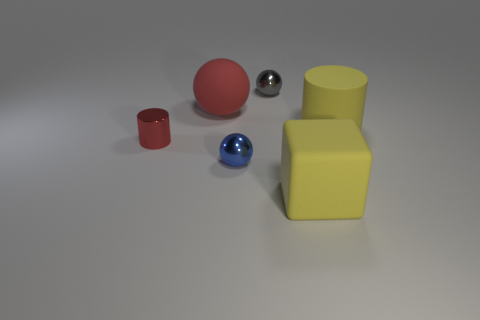Add 2 gray metallic balls. How many objects exist? 8 Subtract all cylinders. How many objects are left? 4 Add 2 brown shiny objects. How many brown shiny objects exist? 2 Subtract 0 green cylinders. How many objects are left? 6 Subtract all big yellow rubber things. Subtract all gray things. How many objects are left? 3 Add 5 big rubber cylinders. How many big rubber cylinders are left? 6 